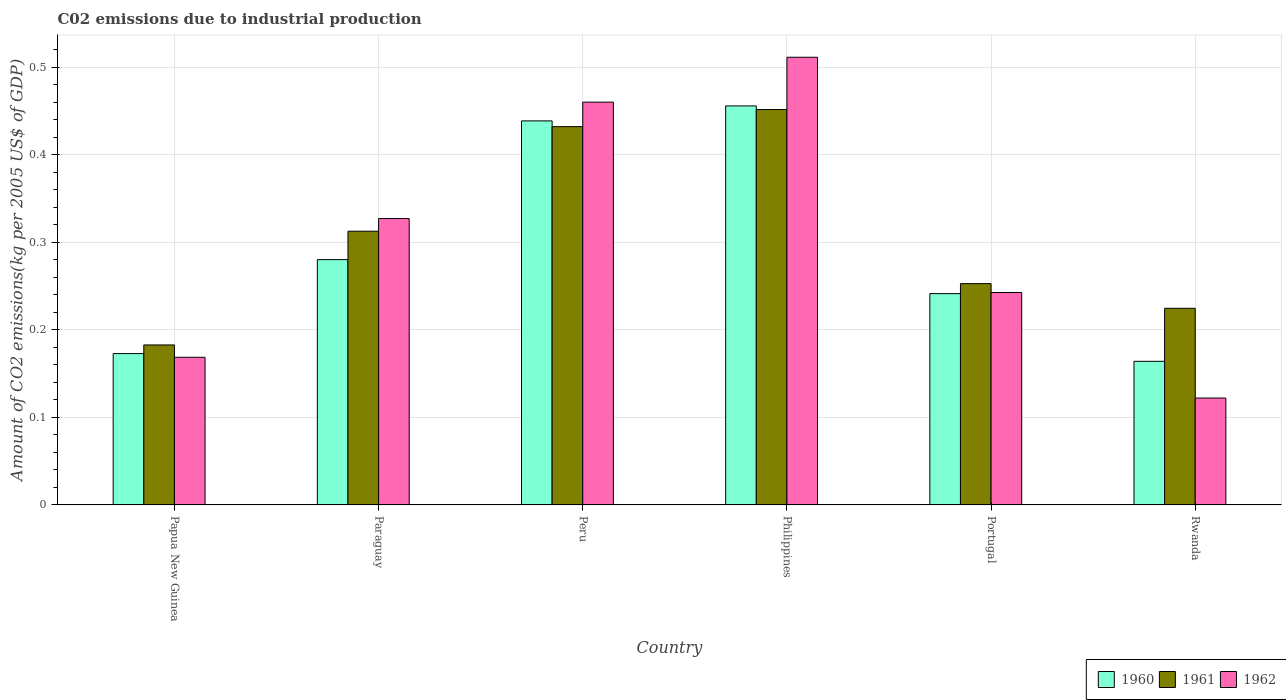How many different coloured bars are there?
Your answer should be very brief. 3. How many bars are there on the 3rd tick from the left?
Offer a very short reply. 3. What is the label of the 4th group of bars from the left?
Offer a very short reply. Philippines. What is the amount of CO2 emitted due to industrial production in 1962 in Papua New Guinea?
Ensure brevity in your answer.  0.17. Across all countries, what is the maximum amount of CO2 emitted due to industrial production in 1961?
Offer a terse response. 0.45. Across all countries, what is the minimum amount of CO2 emitted due to industrial production in 1961?
Give a very brief answer. 0.18. In which country was the amount of CO2 emitted due to industrial production in 1960 minimum?
Your answer should be very brief. Rwanda. What is the total amount of CO2 emitted due to industrial production in 1960 in the graph?
Provide a short and direct response. 1.75. What is the difference between the amount of CO2 emitted due to industrial production in 1960 in Papua New Guinea and that in Peru?
Give a very brief answer. -0.27. What is the difference between the amount of CO2 emitted due to industrial production in 1960 in Philippines and the amount of CO2 emitted due to industrial production in 1962 in Portugal?
Your answer should be very brief. 0.21. What is the average amount of CO2 emitted due to industrial production in 1960 per country?
Make the answer very short. 0.29. What is the difference between the amount of CO2 emitted due to industrial production of/in 1960 and amount of CO2 emitted due to industrial production of/in 1962 in Philippines?
Offer a terse response. -0.06. In how many countries, is the amount of CO2 emitted due to industrial production in 1961 greater than 0.5 kg?
Give a very brief answer. 0. What is the ratio of the amount of CO2 emitted due to industrial production in 1962 in Papua New Guinea to that in Rwanda?
Ensure brevity in your answer.  1.38. Is the amount of CO2 emitted due to industrial production in 1961 in Papua New Guinea less than that in Portugal?
Offer a terse response. Yes. Is the difference between the amount of CO2 emitted due to industrial production in 1960 in Papua New Guinea and Rwanda greater than the difference between the amount of CO2 emitted due to industrial production in 1962 in Papua New Guinea and Rwanda?
Keep it short and to the point. No. What is the difference between the highest and the second highest amount of CO2 emitted due to industrial production in 1962?
Provide a short and direct response. 0.05. What is the difference between the highest and the lowest amount of CO2 emitted due to industrial production in 1960?
Your answer should be very brief. 0.29. What does the 3rd bar from the left in Papua New Guinea represents?
Your answer should be very brief. 1962. How many bars are there?
Give a very brief answer. 18. How many countries are there in the graph?
Make the answer very short. 6. What is the difference between two consecutive major ticks on the Y-axis?
Ensure brevity in your answer.  0.1. How are the legend labels stacked?
Keep it short and to the point. Horizontal. What is the title of the graph?
Give a very brief answer. C02 emissions due to industrial production. Does "2006" appear as one of the legend labels in the graph?
Your response must be concise. No. What is the label or title of the X-axis?
Offer a very short reply. Country. What is the label or title of the Y-axis?
Keep it short and to the point. Amount of CO2 emissions(kg per 2005 US$ of GDP). What is the Amount of CO2 emissions(kg per 2005 US$ of GDP) of 1960 in Papua New Guinea?
Keep it short and to the point. 0.17. What is the Amount of CO2 emissions(kg per 2005 US$ of GDP) of 1961 in Papua New Guinea?
Offer a very short reply. 0.18. What is the Amount of CO2 emissions(kg per 2005 US$ of GDP) of 1962 in Papua New Guinea?
Your response must be concise. 0.17. What is the Amount of CO2 emissions(kg per 2005 US$ of GDP) of 1960 in Paraguay?
Your answer should be very brief. 0.28. What is the Amount of CO2 emissions(kg per 2005 US$ of GDP) of 1961 in Paraguay?
Your response must be concise. 0.31. What is the Amount of CO2 emissions(kg per 2005 US$ of GDP) in 1962 in Paraguay?
Provide a short and direct response. 0.33. What is the Amount of CO2 emissions(kg per 2005 US$ of GDP) in 1960 in Peru?
Make the answer very short. 0.44. What is the Amount of CO2 emissions(kg per 2005 US$ of GDP) in 1961 in Peru?
Your answer should be very brief. 0.43. What is the Amount of CO2 emissions(kg per 2005 US$ of GDP) of 1962 in Peru?
Make the answer very short. 0.46. What is the Amount of CO2 emissions(kg per 2005 US$ of GDP) of 1960 in Philippines?
Give a very brief answer. 0.46. What is the Amount of CO2 emissions(kg per 2005 US$ of GDP) in 1961 in Philippines?
Your answer should be compact. 0.45. What is the Amount of CO2 emissions(kg per 2005 US$ of GDP) of 1962 in Philippines?
Ensure brevity in your answer.  0.51. What is the Amount of CO2 emissions(kg per 2005 US$ of GDP) of 1960 in Portugal?
Make the answer very short. 0.24. What is the Amount of CO2 emissions(kg per 2005 US$ of GDP) of 1961 in Portugal?
Your response must be concise. 0.25. What is the Amount of CO2 emissions(kg per 2005 US$ of GDP) of 1962 in Portugal?
Your answer should be very brief. 0.24. What is the Amount of CO2 emissions(kg per 2005 US$ of GDP) of 1960 in Rwanda?
Provide a short and direct response. 0.16. What is the Amount of CO2 emissions(kg per 2005 US$ of GDP) in 1961 in Rwanda?
Make the answer very short. 0.22. What is the Amount of CO2 emissions(kg per 2005 US$ of GDP) of 1962 in Rwanda?
Offer a terse response. 0.12. Across all countries, what is the maximum Amount of CO2 emissions(kg per 2005 US$ of GDP) of 1960?
Give a very brief answer. 0.46. Across all countries, what is the maximum Amount of CO2 emissions(kg per 2005 US$ of GDP) of 1961?
Your response must be concise. 0.45. Across all countries, what is the maximum Amount of CO2 emissions(kg per 2005 US$ of GDP) in 1962?
Your answer should be very brief. 0.51. Across all countries, what is the minimum Amount of CO2 emissions(kg per 2005 US$ of GDP) of 1960?
Provide a short and direct response. 0.16. Across all countries, what is the minimum Amount of CO2 emissions(kg per 2005 US$ of GDP) in 1961?
Provide a succinct answer. 0.18. Across all countries, what is the minimum Amount of CO2 emissions(kg per 2005 US$ of GDP) of 1962?
Your response must be concise. 0.12. What is the total Amount of CO2 emissions(kg per 2005 US$ of GDP) in 1960 in the graph?
Give a very brief answer. 1.75. What is the total Amount of CO2 emissions(kg per 2005 US$ of GDP) of 1961 in the graph?
Ensure brevity in your answer.  1.86. What is the total Amount of CO2 emissions(kg per 2005 US$ of GDP) in 1962 in the graph?
Keep it short and to the point. 1.83. What is the difference between the Amount of CO2 emissions(kg per 2005 US$ of GDP) in 1960 in Papua New Guinea and that in Paraguay?
Provide a short and direct response. -0.11. What is the difference between the Amount of CO2 emissions(kg per 2005 US$ of GDP) of 1961 in Papua New Guinea and that in Paraguay?
Your response must be concise. -0.13. What is the difference between the Amount of CO2 emissions(kg per 2005 US$ of GDP) of 1962 in Papua New Guinea and that in Paraguay?
Offer a very short reply. -0.16. What is the difference between the Amount of CO2 emissions(kg per 2005 US$ of GDP) of 1960 in Papua New Guinea and that in Peru?
Provide a short and direct response. -0.27. What is the difference between the Amount of CO2 emissions(kg per 2005 US$ of GDP) in 1961 in Papua New Guinea and that in Peru?
Your answer should be compact. -0.25. What is the difference between the Amount of CO2 emissions(kg per 2005 US$ of GDP) of 1962 in Papua New Guinea and that in Peru?
Provide a short and direct response. -0.29. What is the difference between the Amount of CO2 emissions(kg per 2005 US$ of GDP) of 1960 in Papua New Guinea and that in Philippines?
Offer a terse response. -0.28. What is the difference between the Amount of CO2 emissions(kg per 2005 US$ of GDP) of 1961 in Papua New Guinea and that in Philippines?
Offer a very short reply. -0.27. What is the difference between the Amount of CO2 emissions(kg per 2005 US$ of GDP) of 1962 in Papua New Guinea and that in Philippines?
Offer a very short reply. -0.34. What is the difference between the Amount of CO2 emissions(kg per 2005 US$ of GDP) in 1960 in Papua New Guinea and that in Portugal?
Your answer should be very brief. -0.07. What is the difference between the Amount of CO2 emissions(kg per 2005 US$ of GDP) of 1961 in Papua New Guinea and that in Portugal?
Provide a succinct answer. -0.07. What is the difference between the Amount of CO2 emissions(kg per 2005 US$ of GDP) of 1962 in Papua New Guinea and that in Portugal?
Provide a short and direct response. -0.07. What is the difference between the Amount of CO2 emissions(kg per 2005 US$ of GDP) in 1960 in Papua New Guinea and that in Rwanda?
Ensure brevity in your answer.  0.01. What is the difference between the Amount of CO2 emissions(kg per 2005 US$ of GDP) of 1961 in Papua New Guinea and that in Rwanda?
Your response must be concise. -0.04. What is the difference between the Amount of CO2 emissions(kg per 2005 US$ of GDP) of 1962 in Papua New Guinea and that in Rwanda?
Your answer should be compact. 0.05. What is the difference between the Amount of CO2 emissions(kg per 2005 US$ of GDP) in 1960 in Paraguay and that in Peru?
Ensure brevity in your answer.  -0.16. What is the difference between the Amount of CO2 emissions(kg per 2005 US$ of GDP) in 1961 in Paraguay and that in Peru?
Ensure brevity in your answer.  -0.12. What is the difference between the Amount of CO2 emissions(kg per 2005 US$ of GDP) of 1962 in Paraguay and that in Peru?
Your answer should be compact. -0.13. What is the difference between the Amount of CO2 emissions(kg per 2005 US$ of GDP) of 1960 in Paraguay and that in Philippines?
Keep it short and to the point. -0.18. What is the difference between the Amount of CO2 emissions(kg per 2005 US$ of GDP) of 1961 in Paraguay and that in Philippines?
Make the answer very short. -0.14. What is the difference between the Amount of CO2 emissions(kg per 2005 US$ of GDP) in 1962 in Paraguay and that in Philippines?
Keep it short and to the point. -0.18. What is the difference between the Amount of CO2 emissions(kg per 2005 US$ of GDP) in 1960 in Paraguay and that in Portugal?
Your answer should be very brief. 0.04. What is the difference between the Amount of CO2 emissions(kg per 2005 US$ of GDP) in 1961 in Paraguay and that in Portugal?
Keep it short and to the point. 0.06. What is the difference between the Amount of CO2 emissions(kg per 2005 US$ of GDP) of 1962 in Paraguay and that in Portugal?
Your response must be concise. 0.08. What is the difference between the Amount of CO2 emissions(kg per 2005 US$ of GDP) in 1960 in Paraguay and that in Rwanda?
Provide a succinct answer. 0.12. What is the difference between the Amount of CO2 emissions(kg per 2005 US$ of GDP) in 1961 in Paraguay and that in Rwanda?
Ensure brevity in your answer.  0.09. What is the difference between the Amount of CO2 emissions(kg per 2005 US$ of GDP) of 1962 in Paraguay and that in Rwanda?
Your answer should be very brief. 0.2. What is the difference between the Amount of CO2 emissions(kg per 2005 US$ of GDP) of 1960 in Peru and that in Philippines?
Make the answer very short. -0.02. What is the difference between the Amount of CO2 emissions(kg per 2005 US$ of GDP) in 1961 in Peru and that in Philippines?
Keep it short and to the point. -0.02. What is the difference between the Amount of CO2 emissions(kg per 2005 US$ of GDP) of 1962 in Peru and that in Philippines?
Offer a very short reply. -0.05. What is the difference between the Amount of CO2 emissions(kg per 2005 US$ of GDP) in 1960 in Peru and that in Portugal?
Make the answer very short. 0.2. What is the difference between the Amount of CO2 emissions(kg per 2005 US$ of GDP) of 1961 in Peru and that in Portugal?
Ensure brevity in your answer.  0.18. What is the difference between the Amount of CO2 emissions(kg per 2005 US$ of GDP) in 1962 in Peru and that in Portugal?
Keep it short and to the point. 0.22. What is the difference between the Amount of CO2 emissions(kg per 2005 US$ of GDP) in 1960 in Peru and that in Rwanda?
Your answer should be very brief. 0.27. What is the difference between the Amount of CO2 emissions(kg per 2005 US$ of GDP) in 1961 in Peru and that in Rwanda?
Keep it short and to the point. 0.21. What is the difference between the Amount of CO2 emissions(kg per 2005 US$ of GDP) in 1962 in Peru and that in Rwanda?
Keep it short and to the point. 0.34. What is the difference between the Amount of CO2 emissions(kg per 2005 US$ of GDP) of 1960 in Philippines and that in Portugal?
Ensure brevity in your answer.  0.21. What is the difference between the Amount of CO2 emissions(kg per 2005 US$ of GDP) in 1961 in Philippines and that in Portugal?
Offer a very short reply. 0.2. What is the difference between the Amount of CO2 emissions(kg per 2005 US$ of GDP) of 1962 in Philippines and that in Portugal?
Ensure brevity in your answer.  0.27. What is the difference between the Amount of CO2 emissions(kg per 2005 US$ of GDP) in 1960 in Philippines and that in Rwanda?
Provide a succinct answer. 0.29. What is the difference between the Amount of CO2 emissions(kg per 2005 US$ of GDP) of 1961 in Philippines and that in Rwanda?
Keep it short and to the point. 0.23. What is the difference between the Amount of CO2 emissions(kg per 2005 US$ of GDP) of 1962 in Philippines and that in Rwanda?
Your response must be concise. 0.39. What is the difference between the Amount of CO2 emissions(kg per 2005 US$ of GDP) in 1960 in Portugal and that in Rwanda?
Keep it short and to the point. 0.08. What is the difference between the Amount of CO2 emissions(kg per 2005 US$ of GDP) of 1961 in Portugal and that in Rwanda?
Give a very brief answer. 0.03. What is the difference between the Amount of CO2 emissions(kg per 2005 US$ of GDP) of 1962 in Portugal and that in Rwanda?
Provide a succinct answer. 0.12. What is the difference between the Amount of CO2 emissions(kg per 2005 US$ of GDP) of 1960 in Papua New Guinea and the Amount of CO2 emissions(kg per 2005 US$ of GDP) of 1961 in Paraguay?
Offer a very short reply. -0.14. What is the difference between the Amount of CO2 emissions(kg per 2005 US$ of GDP) in 1960 in Papua New Guinea and the Amount of CO2 emissions(kg per 2005 US$ of GDP) in 1962 in Paraguay?
Your answer should be compact. -0.15. What is the difference between the Amount of CO2 emissions(kg per 2005 US$ of GDP) in 1961 in Papua New Guinea and the Amount of CO2 emissions(kg per 2005 US$ of GDP) in 1962 in Paraguay?
Your response must be concise. -0.14. What is the difference between the Amount of CO2 emissions(kg per 2005 US$ of GDP) of 1960 in Papua New Guinea and the Amount of CO2 emissions(kg per 2005 US$ of GDP) of 1961 in Peru?
Make the answer very short. -0.26. What is the difference between the Amount of CO2 emissions(kg per 2005 US$ of GDP) in 1960 in Papua New Guinea and the Amount of CO2 emissions(kg per 2005 US$ of GDP) in 1962 in Peru?
Make the answer very short. -0.29. What is the difference between the Amount of CO2 emissions(kg per 2005 US$ of GDP) of 1961 in Papua New Guinea and the Amount of CO2 emissions(kg per 2005 US$ of GDP) of 1962 in Peru?
Provide a succinct answer. -0.28. What is the difference between the Amount of CO2 emissions(kg per 2005 US$ of GDP) of 1960 in Papua New Guinea and the Amount of CO2 emissions(kg per 2005 US$ of GDP) of 1961 in Philippines?
Give a very brief answer. -0.28. What is the difference between the Amount of CO2 emissions(kg per 2005 US$ of GDP) in 1960 in Papua New Guinea and the Amount of CO2 emissions(kg per 2005 US$ of GDP) in 1962 in Philippines?
Provide a short and direct response. -0.34. What is the difference between the Amount of CO2 emissions(kg per 2005 US$ of GDP) of 1961 in Papua New Guinea and the Amount of CO2 emissions(kg per 2005 US$ of GDP) of 1962 in Philippines?
Ensure brevity in your answer.  -0.33. What is the difference between the Amount of CO2 emissions(kg per 2005 US$ of GDP) of 1960 in Papua New Guinea and the Amount of CO2 emissions(kg per 2005 US$ of GDP) of 1961 in Portugal?
Your answer should be very brief. -0.08. What is the difference between the Amount of CO2 emissions(kg per 2005 US$ of GDP) in 1960 in Papua New Guinea and the Amount of CO2 emissions(kg per 2005 US$ of GDP) in 1962 in Portugal?
Provide a short and direct response. -0.07. What is the difference between the Amount of CO2 emissions(kg per 2005 US$ of GDP) in 1961 in Papua New Guinea and the Amount of CO2 emissions(kg per 2005 US$ of GDP) in 1962 in Portugal?
Keep it short and to the point. -0.06. What is the difference between the Amount of CO2 emissions(kg per 2005 US$ of GDP) in 1960 in Papua New Guinea and the Amount of CO2 emissions(kg per 2005 US$ of GDP) in 1961 in Rwanda?
Make the answer very short. -0.05. What is the difference between the Amount of CO2 emissions(kg per 2005 US$ of GDP) of 1960 in Papua New Guinea and the Amount of CO2 emissions(kg per 2005 US$ of GDP) of 1962 in Rwanda?
Provide a short and direct response. 0.05. What is the difference between the Amount of CO2 emissions(kg per 2005 US$ of GDP) in 1961 in Papua New Guinea and the Amount of CO2 emissions(kg per 2005 US$ of GDP) in 1962 in Rwanda?
Your answer should be very brief. 0.06. What is the difference between the Amount of CO2 emissions(kg per 2005 US$ of GDP) in 1960 in Paraguay and the Amount of CO2 emissions(kg per 2005 US$ of GDP) in 1961 in Peru?
Provide a succinct answer. -0.15. What is the difference between the Amount of CO2 emissions(kg per 2005 US$ of GDP) of 1960 in Paraguay and the Amount of CO2 emissions(kg per 2005 US$ of GDP) of 1962 in Peru?
Ensure brevity in your answer.  -0.18. What is the difference between the Amount of CO2 emissions(kg per 2005 US$ of GDP) in 1961 in Paraguay and the Amount of CO2 emissions(kg per 2005 US$ of GDP) in 1962 in Peru?
Provide a succinct answer. -0.15. What is the difference between the Amount of CO2 emissions(kg per 2005 US$ of GDP) of 1960 in Paraguay and the Amount of CO2 emissions(kg per 2005 US$ of GDP) of 1961 in Philippines?
Make the answer very short. -0.17. What is the difference between the Amount of CO2 emissions(kg per 2005 US$ of GDP) in 1960 in Paraguay and the Amount of CO2 emissions(kg per 2005 US$ of GDP) in 1962 in Philippines?
Ensure brevity in your answer.  -0.23. What is the difference between the Amount of CO2 emissions(kg per 2005 US$ of GDP) in 1961 in Paraguay and the Amount of CO2 emissions(kg per 2005 US$ of GDP) in 1962 in Philippines?
Offer a very short reply. -0.2. What is the difference between the Amount of CO2 emissions(kg per 2005 US$ of GDP) in 1960 in Paraguay and the Amount of CO2 emissions(kg per 2005 US$ of GDP) in 1961 in Portugal?
Make the answer very short. 0.03. What is the difference between the Amount of CO2 emissions(kg per 2005 US$ of GDP) in 1960 in Paraguay and the Amount of CO2 emissions(kg per 2005 US$ of GDP) in 1962 in Portugal?
Offer a very short reply. 0.04. What is the difference between the Amount of CO2 emissions(kg per 2005 US$ of GDP) of 1961 in Paraguay and the Amount of CO2 emissions(kg per 2005 US$ of GDP) of 1962 in Portugal?
Provide a short and direct response. 0.07. What is the difference between the Amount of CO2 emissions(kg per 2005 US$ of GDP) of 1960 in Paraguay and the Amount of CO2 emissions(kg per 2005 US$ of GDP) of 1961 in Rwanda?
Keep it short and to the point. 0.06. What is the difference between the Amount of CO2 emissions(kg per 2005 US$ of GDP) in 1960 in Paraguay and the Amount of CO2 emissions(kg per 2005 US$ of GDP) in 1962 in Rwanda?
Offer a very short reply. 0.16. What is the difference between the Amount of CO2 emissions(kg per 2005 US$ of GDP) in 1961 in Paraguay and the Amount of CO2 emissions(kg per 2005 US$ of GDP) in 1962 in Rwanda?
Make the answer very short. 0.19. What is the difference between the Amount of CO2 emissions(kg per 2005 US$ of GDP) of 1960 in Peru and the Amount of CO2 emissions(kg per 2005 US$ of GDP) of 1961 in Philippines?
Ensure brevity in your answer.  -0.01. What is the difference between the Amount of CO2 emissions(kg per 2005 US$ of GDP) in 1960 in Peru and the Amount of CO2 emissions(kg per 2005 US$ of GDP) in 1962 in Philippines?
Provide a short and direct response. -0.07. What is the difference between the Amount of CO2 emissions(kg per 2005 US$ of GDP) of 1961 in Peru and the Amount of CO2 emissions(kg per 2005 US$ of GDP) of 1962 in Philippines?
Your response must be concise. -0.08. What is the difference between the Amount of CO2 emissions(kg per 2005 US$ of GDP) of 1960 in Peru and the Amount of CO2 emissions(kg per 2005 US$ of GDP) of 1961 in Portugal?
Provide a short and direct response. 0.19. What is the difference between the Amount of CO2 emissions(kg per 2005 US$ of GDP) of 1960 in Peru and the Amount of CO2 emissions(kg per 2005 US$ of GDP) of 1962 in Portugal?
Make the answer very short. 0.2. What is the difference between the Amount of CO2 emissions(kg per 2005 US$ of GDP) in 1961 in Peru and the Amount of CO2 emissions(kg per 2005 US$ of GDP) in 1962 in Portugal?
Ensure brevity in your answer.  0.19. What is the difference between the Amount of CO2 emissions(kg per 2005 US$ of GDP) in 1960 in Peru and the Amount of CO2 emissions(kg per 2005 US$ of GDP) in 1961 in Rwanda?
Your answer should be very brief. 0.21. What is the difference between the Amount of CO2 emissions(kg per 2005 US$ of GDP) of 1960 in Peru and the Amount of CO2 emissions(kg per 2005 US$ of GDP) of 1962 in Rwanda?
Make the answer very short. 0.32. What is the difference between the Amount of CO2 emissions(kg per 2005 US$ of GDP) of 1961 in Peru and the Amount of CO2 emissions(kg per 2005 US$ of GDP) of 1962 in Rwanda?
Make the answer very short. 0.31. What is the difference between the Amount of CO2 emissions(kg per 2005 US$ of GDP) of 1960 in Philippines and the Amount of CO2 emissions(kg per 2005 US$ of GDP) of 1961 in Portugal?
Offer a very short reply. 0.2. What is the difference between the Amount of CO2 emissions(kg per 2005 US$ of GDP) in 1960 in Philippines and the Amount of CO2 emissions(kg per 2005 US$ of GDP) in 1962 in Portugal?
Provide a short and direct response. 0.21. What is the difference between the Amount of CO2 emissions(kg per 2005 US$ of GDP) of 1961 in Philippines and the Amount of CO2 emissions(kg per 2005 US$ of GDP) of 1962 in Portugal?
Offer a terse response. 0.21. What is the difference between the Amount of CO2 emissions(kg per 2005 US$ of GDP) in 1960 in Philippines and the Amount of CO2 emissions(kg per 2005 US$ of GDP) in 1961 in Rwanda?
Offer a terse response. 0.23. What is the difference between the Amount of CO2 emissions(kg per 2005 US$ of GDP) of 1960 in Philippines and the Amount of CO2 emissions(kg per 2005 US$ of GDP) of 1962 in Rwanda?
Make the answer very short. 0.33. What is the difference between the Amount of CO2 emissions(kg per 2005 US$ of GDP) in 1961 in Philippines and the Amount of CO2 emissions(kg per 2005 US$ of GDP) in 1962 in Rwanda?
Provide a succinct answer. 0.33. What is the difference between the Amount of CO2 emissions(kg per 2005 US$ of GDP) of 1960 in Portugal and the Amount of CO2 emissions(kg per 2005 US$ of GDP) of 1961 in Rwanda?
Ensure brevity in your answer.  0.02. What is the difference between the Amount of CO2 emissions(kg per 2005 US$ of GDP) of 1960 in Portugal and the Amount of CO2 emissions(kg per 2005 US$ of GDP) of 1962 in Rwanda?
Your answer should be very brief. 0.12. What is the difference between the Amount of CO2 emissions(kg per 2005 US$ of GDP) of 1961 in Portugal and the Amount of CO2 emissions(kg per 2005 US$ of GDP) of 1962 in Rwanda?
Give a very brief answer. 0.13. What is the average Amount of CO2 emissions(kg per 2005 US$ of GDP) in 1960 per country?
Keep it short and to the point. 0.29. What is the average Amount of CO2 emissions(kg per 2005 US$ of GDP) in 1961 per country?
Offer a very short reply. 0.31. What is the average Amount of CO2 emissions(kg per 2005 US$ of GDP) in 1962 per country?
Your response must be concise. 0.31. What is the difference between the Amount of CO2 emissions(kg per 2005 US$ of GDP) of 1960 and Amount of CO2 emissions(kg per 2005 US$ of GDP) of 1961 in Papua New Guinea?
Offer a terse response. -0.01. What is the difference between the Amount of CO2 emissions(kg per 2005 US$ of GDP) of 1960 and Amount of CO2 emissions(kg per 2005 US$ of GDP) of 1962 in Papua New Guinea?
Ensure brevity in your answer.  0. What is the difference between the Amount of CO2 emissions(kg per 2005 US$ of GDP) of 1961 and Amount of CO2 emissions(kg per 2005 US$ of GDP) of 1962 in Papua New Guinea?
Offer a very short reply. 0.01. What is the difference between the Amount of CO2 emissions(kg per 2005 US$ of GDP) of 1960 and Amount of CO2 emissions(kg per 2005 US$ of GDP) of 1961 in Paraguay?
Your answer should be compact. -0.03. What is the difference between the Amount of CO2 emissions(kg per 2005 US$ of GDP) of 1960 and Amount of CO2 emissions(kg per 2005 US$ of GDP) of 1962 in Paraguay?
Ensure brevity in your answer.  -0.05. What is the difference between the Amount of CO2 emissions(kg per 2005 US$ of GDP) in 1961 and Amount of CO2 emissions(kg per 2005 US$ of GDP) in 1962 in Paraguay?
Give a very brief answer. -0.01. What is the difference between the Amount of CO2 emissions(kg per 2005 US$ of GDP) in 1960 and Amount of CO2 emissions(kg per 2005 US$ of GDP) in 1961 in Peru?
Your answer should be compact. 0.01. What is the difference between the Amount of CO2 emissions(kg per 2005 US$ of GDP) of 1960 and Amount of CO2 emissions(kg per 2005 US$ of GDP) of 1962 in Peru?
Offer a very short reply. -0.02. What is the difference between the Amount of CO2 emissions(kg per 2005 US$ of GDP) of 1961 and Amount of CO2 emissions(kg per 2005 US$ of GDP) of 1962 in Peru?
Provide a succinct answer. -0.03. What is the difference between the Amount of CO2 emissions(kg per 2005 US$ of GDP) of 1960 and Amount of CO2 emissions(kg per 2005 US$ of GDP) of 1961 in Philippines?
Your response must be concise. 0. What is the difference between the Amount of CO2 emissions(kg per 2005 US$ of GDP) in 1960 and Amount of CO2 emissions(kg per 2005 US$ of GDP) in 1962 in Philippines?
Ensure brevity in your answer.  -0.06. What is the difference between the Amount of CO2 emissions(kg per 2005 US$ of GDP) of 1961 and Amount of CO2 emissions(kg per 2005 US$ of GDP) of 1962 in Philippines?
Ensure brevity in your answer.  -0.06. What is the difference between the Amount of CO2 emissions(kg per 2005 US$ of GDP) of 1960 and Amount of CO2 emissions(kg per 2005 US$ of GDP) of 1961 in Portugal?
Make the answer very short. -0.01. What is the difference between the Amount of CO2 emissions(kg per 2005 US$ of GDP) of 1960 and Amount of CO2 emissions(kg per 2005 US$ of GDP) of 1962 in Portugal?
Provide a succinct answer. -0. What is the difference between the Amount of CO2 emissions(kg per 2005 US$ of GDP) in 1961 and Amount of CO2 emissions(kg per 2005 US$ of GDP) in 1962 in Portugal?
Your answer should be very brief. 0.01. What is the difference between the Amount of CO2 emissions(kg per 2005 US$ of GDP) of 1960 and Amount of CO2 emissions(kg per 2005 US$ of GDP) of 1961 in Rwanda?
Keep it short and to the point. -0.06. What is the difference between the Amount of CO2 emissions(kg per 2005 US$ of GDP) of 1960 and Amount of CO2 emissions(kg per 2005 US$ of GDP) of 1962 in Rwanda?
Provide a succinct answer. 0.04. What is the difference between the Amount of CO2 emissions(kg per 2005 US$ of GDP) in 1961 and Amount of CO2 emissions(kg per 2005 US$ of GDP) in 1962 in Rwanda?
Your answer should be very brief. 0.1. What is the ratio of the Amount of CO2 emissions(kg per 2005 US$ of GDP) of 1960 in Papua New Guinea to that in Paraguay?
Give a very brief answer. 0.62. What is the ratio of the Amount of CO2 emissions(kg per 2005 US$ of GDP) of 1961 in Papua New Guinea to that in Paraguay?
Provide a succinct answer. 0.58. What is the ratio of the Amount of CO2 emissions(kg per 2005 US$ of GDP) in 1962 in Papua New Guinea to that in Paraguay?
Give a very brief answer. 0.52. What is the ratio of the Amount of CO2 emissions(kg per 2005 US$ of GDP) in 1960 in Papua New Guinea to that in Peru?
Provide a short and direct response. 0.39. What is the ratio of the Amount of CO2 emissions(kg per 2005 US$ of GDP) in 1961 in Papua New Guinea to that in Peru?
Ensure brevity in your answer.  0.42. What is the ratio of the Amount of CO2 emissions(kg per 2005 US$ of GDP) of 1962 in Papua New Guinea to that in Peru?
Provide a short and direct response. 0.37. What is the ratio of the Amount of CO2 emissions(kg per 2005 US$ of GDP) of 1960 in Papua New Guinea to that in Philippines?
Keep it short and to the point. 0.38. What is the ratio of the Amount of CO2 emissions(kg per 2005 US$ of GDP) in 1961 in Papua New Guinea to that in Philippines?
Offer a very short reply. 0.4. What is the ratio of the Amount of CO2 emissions(kg per 2005 US$ of GDP) of 1962 in Papua New Guinea to that in Philippines?
Ensure brevity in your answer.  0.33. What is the ratio of the Amount of CO2 emissions(kg per 2005 US$ of GDP) in 1960 in Papua New Guinea to that in Portugal?
Provide a succinct answer. 0.72. What is the ratio of the Amount of CO2 emissions(kg per 2005 US$ of GDP) in 1961 in Papua New Guinea to that in Portugal?
Your answer should be very brief. 0.72. What is the ratio of the Amount of CO2 emissions(kg per 2005 US$ of GDP) in 1962 in Papua New Guinea to that in Portugal?
Offer a very short reply. 0.7. What is the ratio of the Amount of CO2 emissions(kg per 2005 US$ of GDP) in 1960 in Papua New Guinea to that in Rwanda?
Offer a terse response. 1.05. What is the ratio of the Amount of CO2 emissions(kg per 2005 US$ of GDP) in 1961 in Papua New Guinea to that in Rwanda?
Offer a very short reply. 0.81. What is the ratio of the Amount of CO2 emissions(kg per 2005 US$ of GDP) of 1962 in Papua New Guinea to that in Rwanda?
Give a very brief answer. 1.38. What is the ratio of the Amount of CO2 emissions(kg per 2005 US$ of GDP) in 1960 in Paraguay to that in Peru?
Ensure brevity in your answer.  0.64. What is the ratio of the Amount of CO2 emissions(kg per 2005 US$ of GDP) of 1961 in Paraguay to that in Peru?
Offer a very short reply. 0.72. What is the ratio of the Amount of CO2 emissions(kg per 2005 US$ of GDP) in 1962 in Paraguay to that in Peru?
Make the answer very short. 0.71. What is the ratio of the Amount of CO2 emissions(kg per 2005 US$ of GDP) of 1960 in Paraguay to that in Philippines?
Give a very brief answer. 0.61. What is the ratio of the Amount of CO2 emissions(kg per 2005 US$ of GDP) in 1961 in Paraguay to that in Philippines?
Ensure brevity in your answer.  0.69. What is the ratio of the Amount of CO2 emissions(kg per 2005 US$ of GDP) in 1962 in Paraguay to that in Philippines?
Make the answer very short. 0.64. What is the ratio of the Amount of CO2 emissions(kg per 2005 US$ of GDP) in 1960 in Paraguay to that in Portugal?
Offer a very short reply. 1.16. What is the ratio of the Amount of CO2 emissions(kg per 2005 US$ of GDP) of 1961 in Paraguay to that in Portugal?
Provide a succinct answer. 1.24. What is the ratio of the Amount of CO2 emissions(kg per 2005 US$ of GDP) of 1962 in Paraguay to that in Portugal?
Offer a terse response. 1.35. What is the ratio of the Amount of CO2 emissions(kg per 2005 US$ of GDP) of 1960 in Paraguay to that in Rwanda?
Your answer should be compact. 1.71. What is the ratio of the Amount of CO2 emissions(kg per 2005 US$ of GDP) of 1961 in Paraguay to that in Rwanda?
Your answer should be compact. 1.39. What is the ratio of the Amount of CO2 emissions(kg per 2005 US$ of GDP) in 1962 in Paraguay to that in Rwanda?
Offer a terse response. 2.68. What is the ratio of the Amount of CO2 emissions(kg per 2005 US$ of GDP) in 1960 in Peru to that in Philippines?
Make the answer very short. 0.96. What is the ratio of the Amount of CO2 emissions(kg per 2005 US$ of GDP) of 1961 in Peru to that in Philippines?
Give a very brief answer. 0.96. What is the ratio of the Amount of CO2 emissions(kg per 2005 US$ of GDP) in 1962 in Peru to that in Philippines?
Offer a very short reply. 0.9. What is the ratio of the Amount of CO2 emissions(kg per 2005 US$ of GDP) of 1960 in Peru to that in Portugal?
Ensure brevity in your answer.  1.82. What is the ratio of the Amount of CO2 emissions(kg per 2005 US$ of GDP) of 1961 in Peru to that in Portugal?
Offer a terse response. 1.71. What is the ratio of the Amount of CO2 emissions(kg per 2005 US$ of GDP) of 1962 in Peru to that in Portugal?
Give a very brief answer. 1.9. What is the ratio of the Amount of CO2 emissions(kg per 2005 US$ of GDP) in 1960 in Peru to that in Rwanda?
Your response must be concise. 2.67. What is the ratio of the Amount of CO2 emissions(kg per 2005 US$ of GDP) of 1961 in Peru to that in Rwanda?
Keep it short and to the point. 1.92. What is the ratio of the Amount of CO2 emissions(kg per 2005 US$ of GDP) of 1962 in Peru to that in Rwanda?
Ensure brevity in your answer.  3.77. What is the ratio of the Amount of CO2 emissions(kg per 2005 US$ of GDP) of 1960 in Philippines to that in Portugal?
Your response must be concise. 1.89. What is the ratio of the Amount of CO2 emissions(kg per 2005 US$ of GDP) in 1961 in Philippines to that in Portugal?
Provide a succinct answer. 1.79. What is the ratio of the Amount of CO2 emissions(kg per 2005 US$ of GDP) of 1962 in Philippines to that in Portugal?
Offer a very short reply. 2.11. What is the ratio of the Amount of CO2 emissions(kg per 2005 US$ of GDP) of 1960 in Philippines to that in Rwanda?
Your response must be concise. 2.78. What is the ratio of the Amount of CO2 emissions(kg per 2005 US$ of GDP) of 1961 in Philippines to that in Rwanda?
Offer a terse response. 2.01. What is the ratio of the Amount of CO2 emissions(kg per 2005 US$ of GDP) in 1962 in Philippines to that in Rwanda?
Ensure brevity in your answer.  4.19. What is the ratio of the Amount of CO2 emissions(kg per 2005 US$ of GDP) in 1960 in Portugal to that in Rwanda?
Your answer should be compact. 1.47. What is the ratio of the Amount of CO2 emissions(kg per 2005 US$ of GDP) in 1961 in Portugal to that in Rwanda?
Offer a terse response. 1.13. What is the ratio of the Amount of CO2 emissions(kg per 2005 US$ of GDP) of 1962 in Portugal to that in Rwanda?
Make the answer very short. 1.99. What is the difference between the highest and the second highest Amount of CO2 emissions(kg per 2005 US$ of GDP) in 1960?
Offer a very short reply. 0.02. What is the difference between the highest and the second highest Amount of CO2 emissions(kg per 2005 US$ of GDP) in 1961?
Provide a short and direct response. 0.02. What is the difference between the highest and the second highest Amount of CO2 emissions(kg per 2005 US$ of GDP) in 1962?
Give a very brief answer. 0.05. What is the difference between the highest and the lowest Amount of CO2 emissions(kg per 2005 US$ of GDP) of 1960?
Keep it short and to the point. 0.29. What is the difference between the highest and the lowest Amount of CO2 emissions(kg per 2005 US$ of GDP) of 1961?
Ensure brevity in your answer.  0.27. What is the difference between the highest and the lowest Amount of CO2 emissions(kg per 2005 US$ of GDP) of 1962?
Provide a short and direct response. 0.39. 